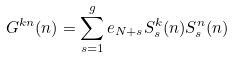Convert formula to latex. <formula><loc_0><loc_0><loc_500><loc_500>G ^ { k n } ( n ) = \sum _ { s = 1 } ^ { g } e _ { N + s } S ^ { k } _ { s } ( n ) S ^ { n } _ { s } ( n )</formula> 